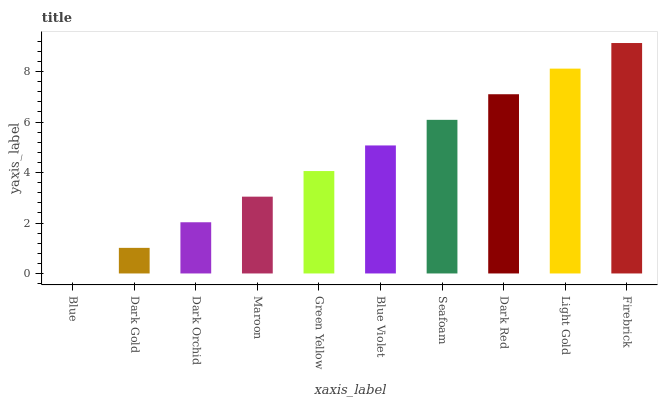Is Blue the minimum?
Answer yes or no. Yes. Is Firebrick the maximum?
Answer yes or no. Yes. Is Dark Gold the minimum?
Answer yes or no. No. Is Dark Gold the maximum?
Answer yes or no. No. Is Dark Gold greater than Blue?
Answer yes or no. Yes. Is Blue less than Dark Gold?
Answer yes or no. Yes. Is Blue greater than Dark Gold?
Answer yes or no. No. Is Dark Gold less than Blue?
Answer yes or no. No. Is Blue Violet the high median?
Answer yes or no. Yes. Is Green Yellow the low median?
Answer yes or no. Yes. Is Light Gold the high median?
Answer yes or no. No. Is Blue Violet the low median?
Answer yes or no. No. 